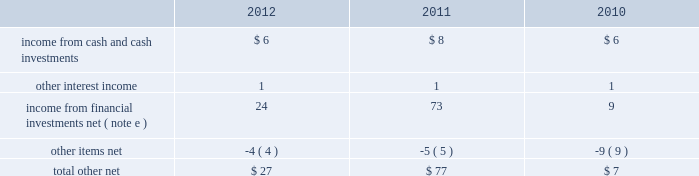Masco corporation notes to consolidated financial statements ( continued ) o .
Segment information ( continued ) ( 1 ) included in net sales were export sales from the u.s .
Of $ 229 million , $ 241 million and $ 246 million in 2012 , 2011 and 2010 , respectively .
( 2 ) excluded from net sales were intra-company sales between segments of approximately two percent of net sales in each of 2012 , 2011 and 2010 .
( 3 ) included in net sales were sales to one customer of $ 2143 million , $ 1984 million and $ 1993 million in 2012 , 2011 and 2010 , respectively .
Such net sales were included in the following segments : cabinets and related products , plumbing products , decorative architectural products and other specialty products .
( 4 ) net sales from the company 2019s operations in the u.s .
Were $ 5793 million , $ 5394 million and $ 5618 million in 2012 , 2011 and 2010 , respectively .
( 5 ) net sales , operating ( loss ) profit , property additions and depreciation and amortization expense for 2012 , 2011 and 2010 excluded the results of businesses reported as discontinued operations in 2012 , 2011 and 2010 .
( 6 ) included in segment operating profit ( loss ) for 2012 was an impairment charge for other intangible assets as follows : other specialty products 2013 $ 42 million .
Included in segment operating ( loss ) profit for 2011 were impairment charges for goodwill and other intangible assets as follows : cabinets and related products 2013 $ 44 million ; plumbing products 2013 $ 1 million ; decorative architectural products 2013 $ 75 million ; and other specialty products 2013 $ 374 million .
Included in segment operating ( loss ) profit for 2010 were impairment charges for goodwill and other intangible assets as follows : plumbing products 2013 $ 1 million ; and installation and other services 2013 $ 697 million .
( 7 ) general corporate expense , net included those expenses not specifically attributable to the company 2019s segments .
( 8 ) the charge for litigation settlement , net in 2012 primarily relates to a business in the installation and other services segment and in 2011 relates to business units in the cabinets and related products and the other specialty products segments .
( 9 ) long-lived assets of the company 2019s operations in the u.s .
And europe were $ 2795 million and $ 567 million , $ 2964 million and $ 565 million , and $ 3684 million and $ 617 million at december 31 , 2012 , 2011 and 2010 , respectively .
( 10 ) segment assets for 2012 and 2011 excluded the assets of businesses reported as discontinued operations in the respective years .
Severance costs as part of the company 2019s continuing review of its operations , actions were taken during 2012 , 2011 and 2010 to respond to market conditions .
The company recorded charges related to severance and early retirement programs of $ 36 million , $ 17 million and $ 14 million for the years ended december 31 , 2012 , 2011 and 2010 , respectively .
Such charges are principally reflected in the statement of operations in selling , general and administrative expenses and were paid when incurred .
Other income ( expense ) , net other , net , which is included in other income ( expense ) , net , was as follows , in millions: .
Other items , net , included realized foreign currency transaction losses of $ 2 million , $ 5 million and $ 2 million in 2012 , 2011 and 2010 , respectively , as well as other miscellaneous items. .
What was the difference in income from financial investments net in millions from 2011 to 2012? 
Computations: (24 - 73)
Answer: -49.0. 